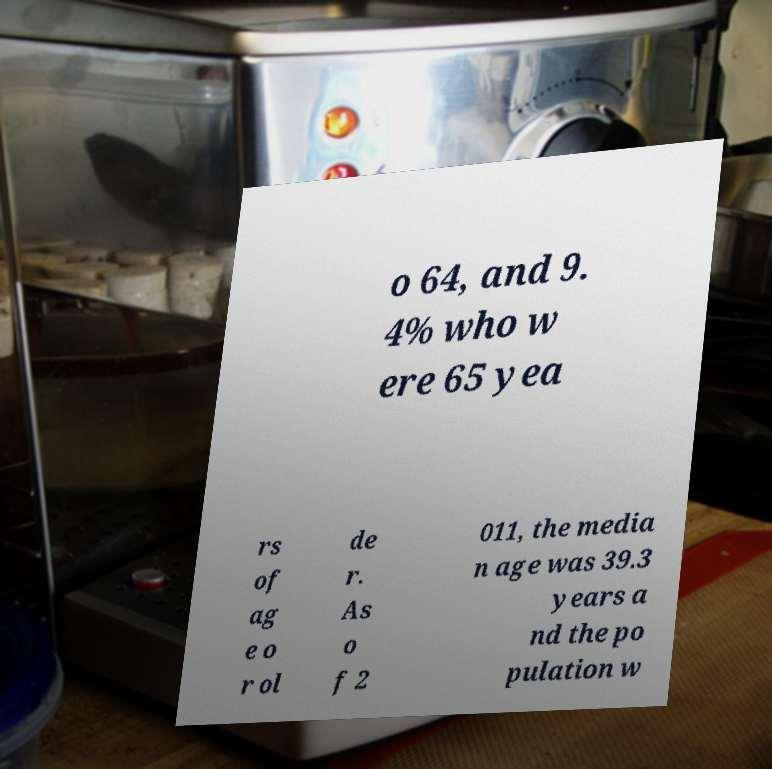What messages or text are displayed in this image? I need them in a readable, typed format. o 64, and 9. 4% who w ere 65 yea rs of ag e o r ol de r. As o f 2 011, the media n age was 39.3 years a nd the po pulation w 